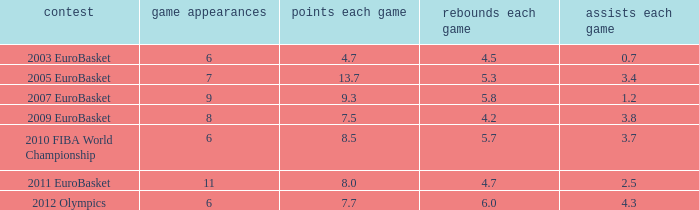How may assists per game have 7.7 points per game? 4.3. 